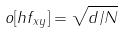<formula> <loc_0><loc_0><loc_500><loc_500>o [ h f _ { x y } ] = \sqrt { d / N }</formula> 